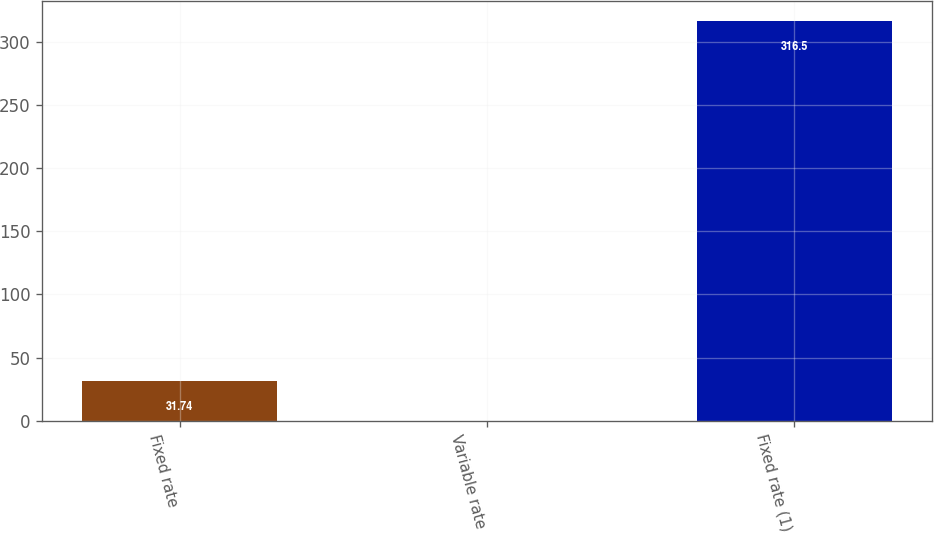Convert chart. <chart><loc_0><loc_0><loc_500><loc_500><bar_chart><fcel>Fixed rate<fcel>Variable rate<fcel>Fixed rate (1)<nl><fcel>31.74<fcel>0.1<fcel>316.5<nl></chart> 